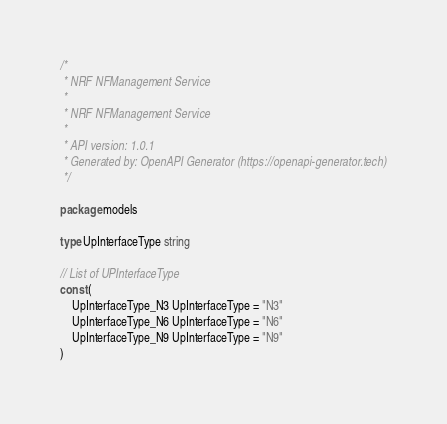Convert code to text. <code><loc_0><loc_0><loc_500><loc_500><_Go_>/*
 * NRF NFManagement Service
 *
 * NRF NFManagement Service
 *
 * API version: 1.0.1
 * Generated by: OpenAPI Generator (https://openapi-generator.tech)
 */

package models

type UpInterfaceType string

// List of UPInterfaceType
const (
	UpInterfaceType_N3 UpInterfaceType = "N3"
	UpInterfaceType_N6 UpInterfaceType = "N6"
	UpInterfaceType_N9 UpInterfaceType = "N9"
)
</code> 